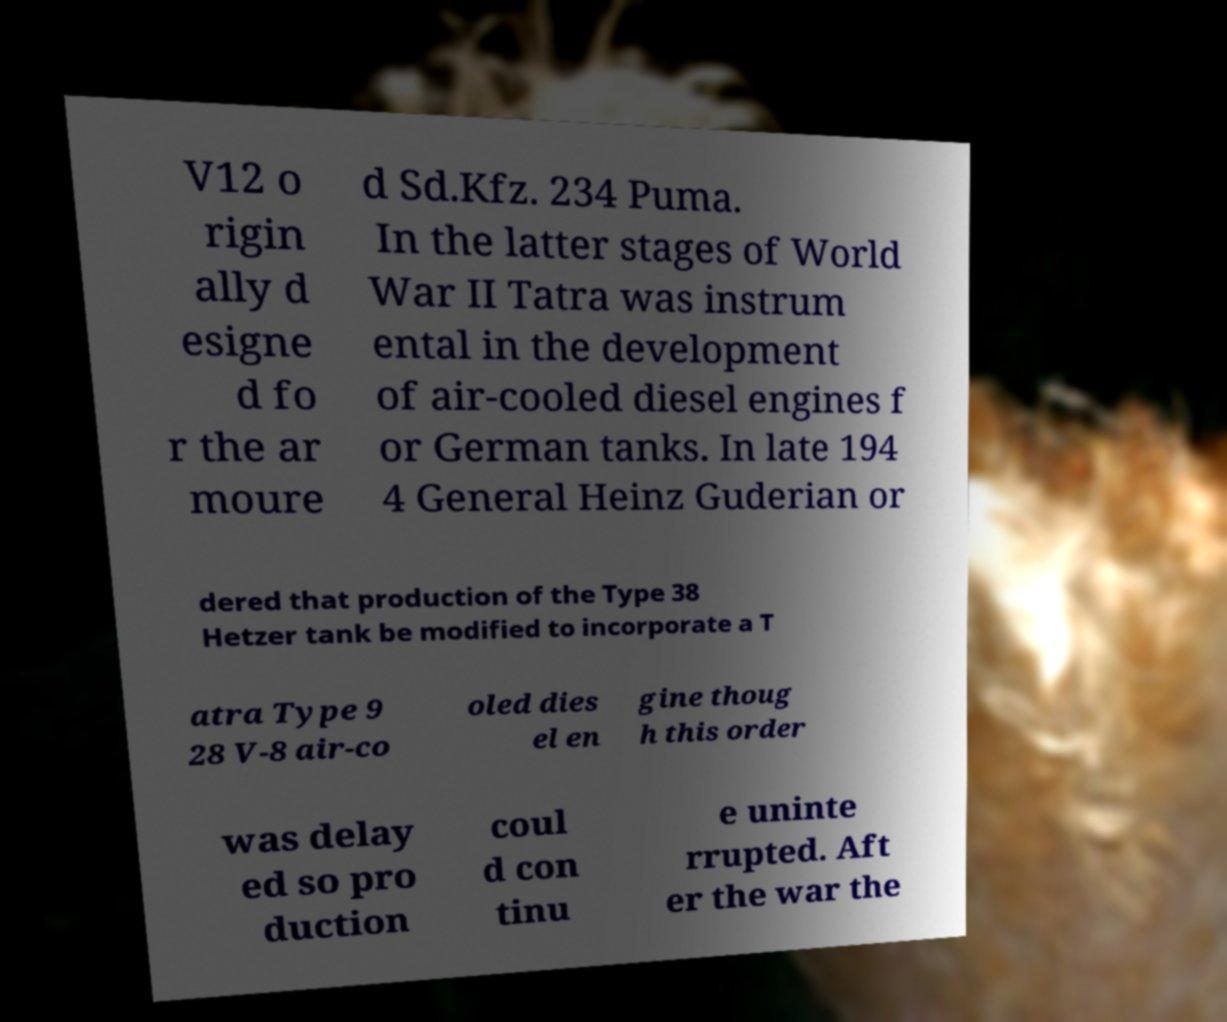Could you assist in decoding the text presented in this image and type it out clearly? V12 o rigin ally d esigne d fo r the ar moure d Sd.Kfz. 234 Puma. In the latter stages of World War II Tatra was instrum ental in the development of air-cooled diesel engines f or German tanks. In late 194 4 General Heinz Guderian or dered that production of the Type 38 Hetzer tank be modified to incorporate a T atra Type 9 28 V-8 air-co oled dies el en gine thoug h this order was delay ed so pro duction coul d con tinu e uninte rrupted. Aft er the war the 